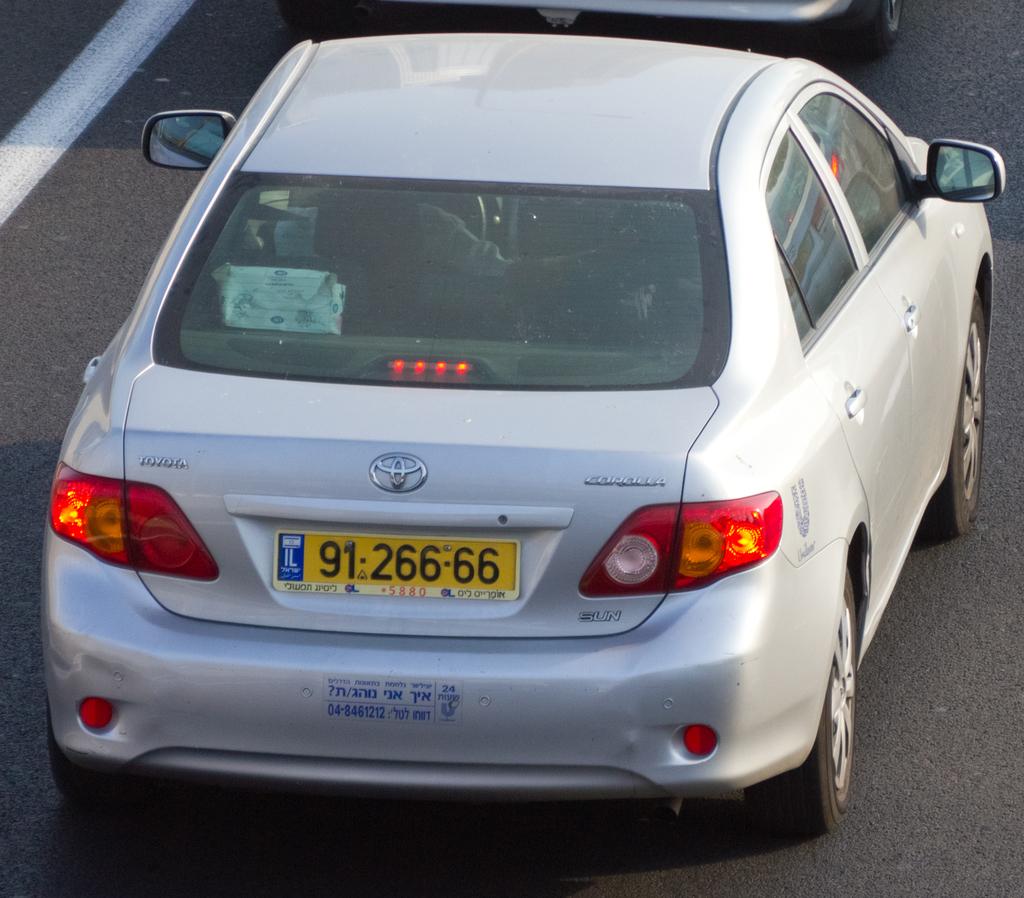What´s the number of the license plate?
Give a very brief answer. 91 266 66. 